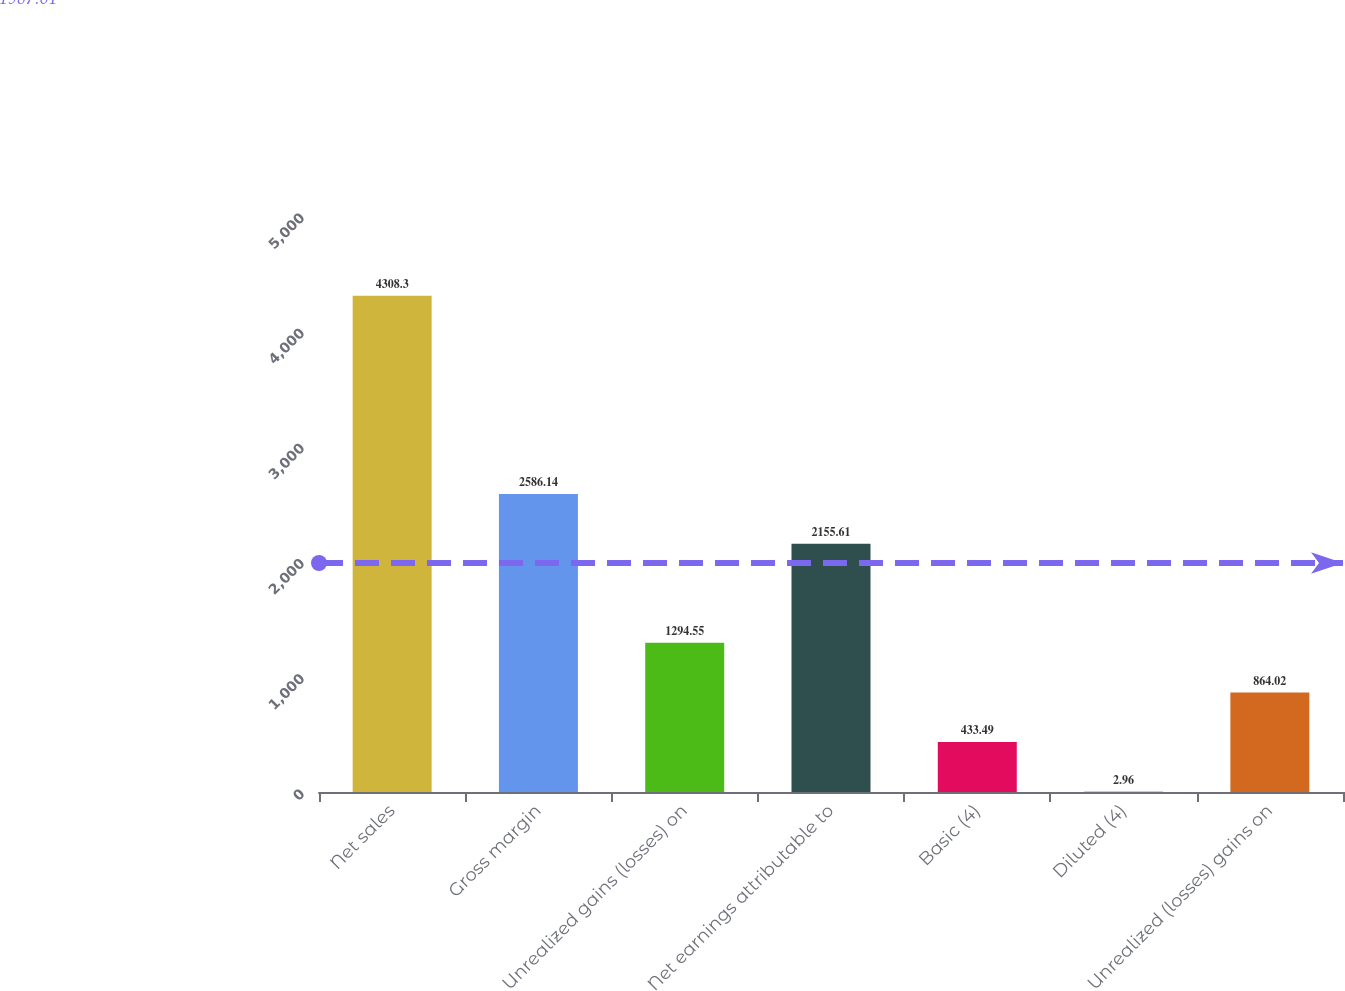Convert chart to OTSL. <chart><loc_0><loc_0><loc_500><loc_500><bar_chart><fcel>Net sales<fcel>Gross margin<fcel>Unrealized gains (losses) on<fcel>Net earnings attributable to<fcel>Basic (4)<fcel>Diluted (4)<fcel>Unrealized (losses) gains on<nl><fcel>4308.3<fcel>2586.14<fcel>1294.55<fcel>2155.61<fcel>433.49<fcel>2.96<fcel>864.02<nl></chart> 